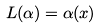<formula> <loc_0><loc_0><loc_500><loc_500>L ( \alpha ) = \alpha ( x )</formula> 